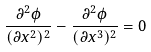Convert formula to latex. <formula><loc_0><loc_0><loc_500><loc_500>\frac { \partial ^ { 2 } \phi } { ( \partial x ^ { 2 } ) ^ { 2 } } - \frac { \partial ^ { 2 } \phi } { ( \partial x ^ { 3 } ) ^ { 2 } } = 0</formula> 